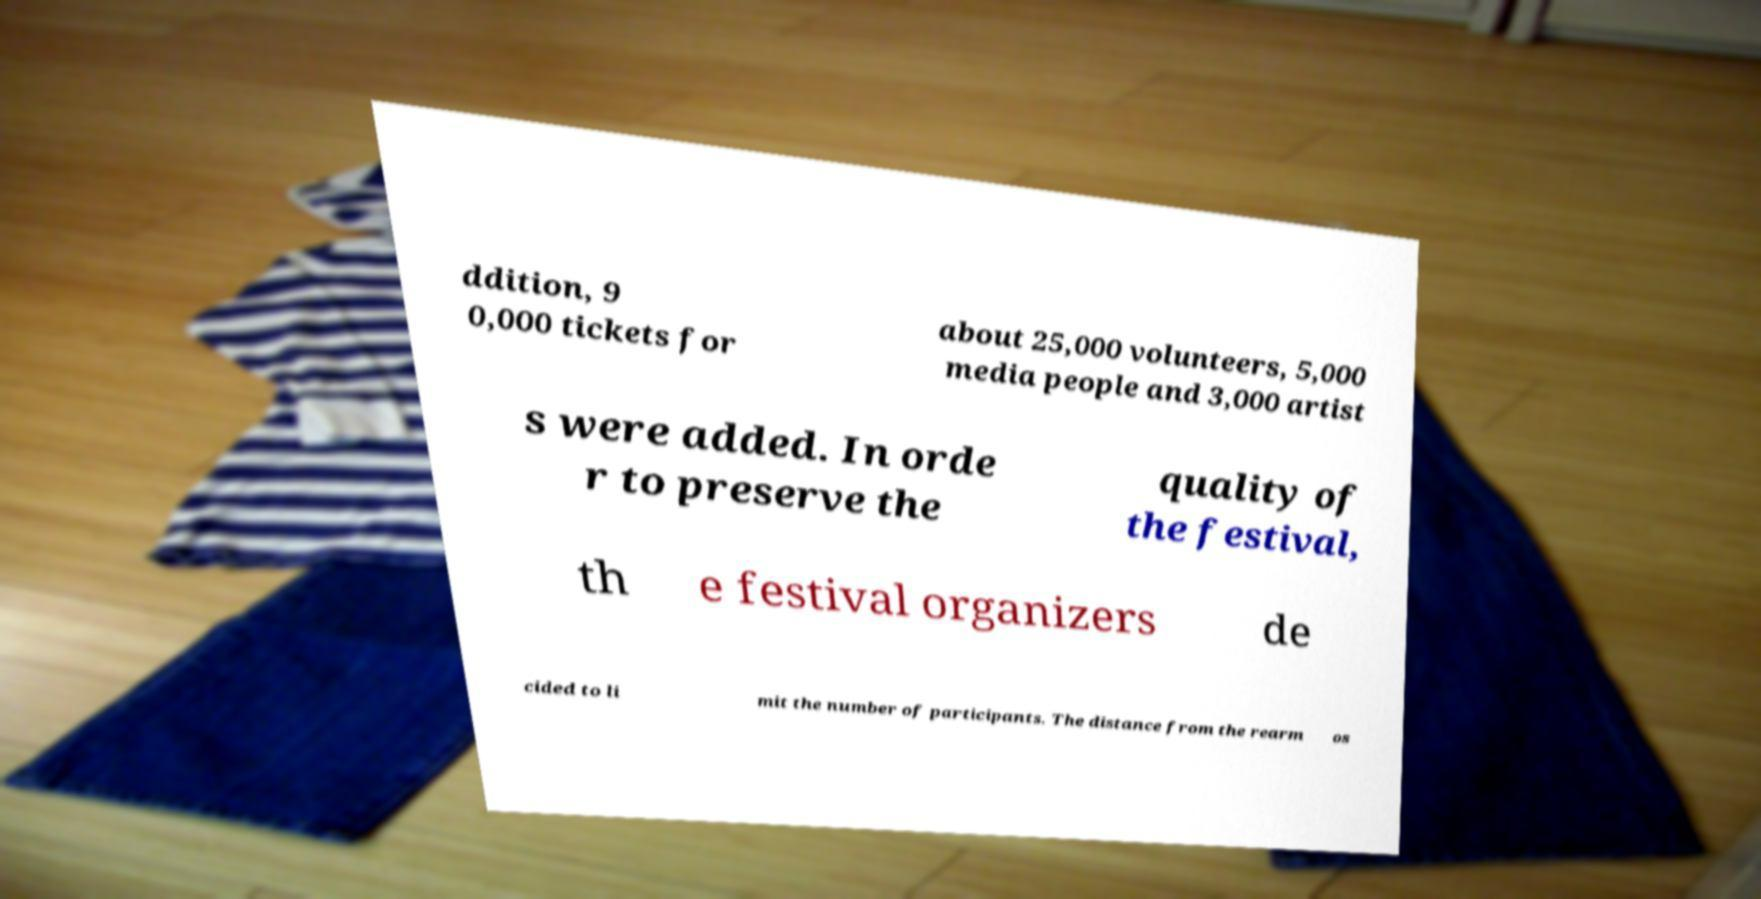There's text embedded in this image that I need extracted. Can you transcribe it verbatim? ddition, 9 0,000 tickets for about 25,000 volunteers, 5,000 media people and 3,000 artist s were added. In orde r to preserve the quality of the festival, th e festival organizers de cided to li mit the number of participants. The distance from the rearm os 